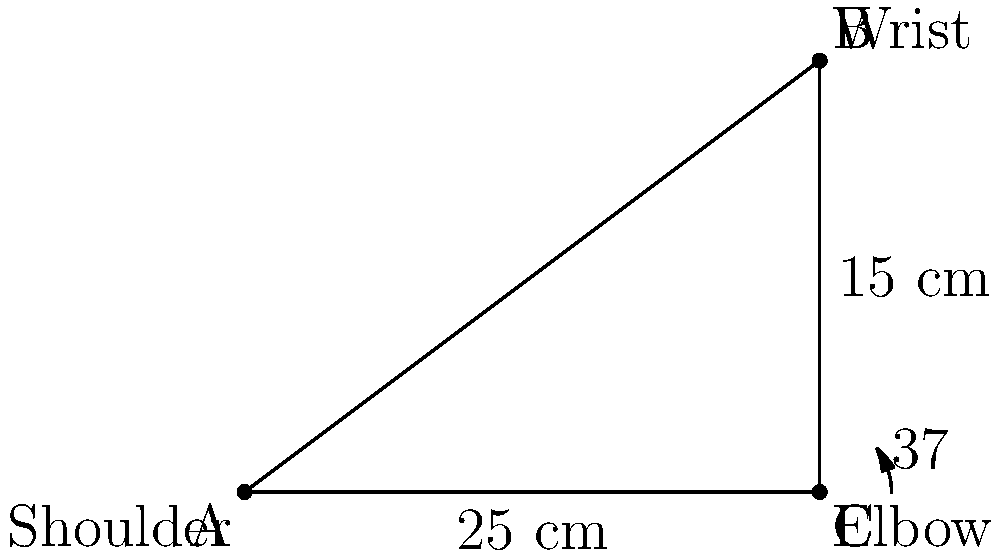As a human resources manager, you're tasked with ordering dress shirts for your company's executives. To ensure a professional appearance, you need to determine the correct sleeve length. If an executive's shoulder-to-wrist measurement is 25 cm and their arm forms a 37° angle at the elbow, what is the length of the shirt sleeve needed to the nearest centimeter? Let's approach this step-by-step using trigonometry:

1) The arm forms a right-angled triangle, with the shoulder-to-wrist measurement as the hypotenuse.

2) We know:
   - The hypotenuse (shoulder to wrist) = 25 cm
   - The angle at the elbow = 37°

3) We need to find the adjacent side of the triangle (shoulder to elbow), which will be the sleeve length.

4) We can use the cosine function:

   $\cos(37°) = \frac{\text{adjacent}}{\text{hypotenuse}}$

5) Rearranging the equation:

   $\text{adjacent} = \text{hypotenuse} \times \cos(37°)$

6) Plugging in the values:

   $\text{sleeve length} = 25 \times \cos(37°)$

7) Using a calculator:

   $\text{sleeve length} = 25 \times 0.7986 = 19.965$ cm

8) Rounding to the nearest centimeter:

   $\text{sleeve length} \approx 20$ cm

Therefore, the shirt sleeve should be 20 cm long to ensure a professional fit.
Answer: 20 cm 